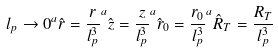Convert formula to latex. <formula><loc_0><loc_0><loc_500><loc_500>l _ { p } \rightarrow 0 ^ { a } \hat { r } = \frac { r } { l _ { p } ^ { 3 } } ^ { a } \hat { z } = \frac { z } { l _ { p } ^ { 3 } } ^ { a } \hat { r } _ { 0 } = \frac { r _ { 0 } } { l _ { p } ^ { 3 } } ^ { a } \hat { R } _ { T } = \frac { R _ { T } } { l _ { p } ^ { 3 } }</formula> 